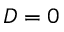<formula> <loc_0><loc_0><loc_500><loc_500>D = 0</formula> 